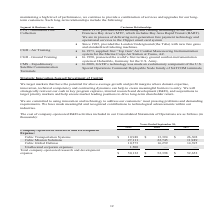According to Cubic's financial document, Which markets does the company target? markets that have the potential for above-average growth and profit margins where domain expertise, innovation, technical competency and contracting dynamics can help to create meaningful barriers to entry.. The document states: "Innovation-focused Investment of Capital We target markets that have the potential for above-average growth and profit margins where domain expertise,..." Also, Where will the company strategically reinvest their cash? in key program captures, internal research and development (R&D), and acquisitions to target priority markets and help ensure market leading positions to drive long-term shareholder return. The document states: "to entry. We will strategically reinvest our cash in key program captures, internal research and development (R&D), and acquisitions to target priorit..." Also, What are the types of company-sponsored R&D activities in the table? The document contains multiple relevant values: Cubic Transportation Systems, Cubic Mission Solutions, Cubic Global Defense, Unallocated corporate expenses. From the document: "Cubic Mission Solutions 27,111 22,745 11,949 Cubic Global Defense 10,573 16,259 14,395 Unallocated corporate expenses 1,500 — — Total company-sponsore..." Also, How many types of company-sponsored R&D activities are there in the table? Counting the relevant items in the document: Cubic Transportation Systems, Cubic Mission Solutions, Cubic Global Defense, Unallocated corporate expenses, I find 4 instances. The key data points involved are: Cubic Global Defense, Cubic Mission Solutions, Cubic Transportation Systems. Also, can you calculate: What is the change in the total company-sponsored research and development expense in 2019 from 2018? Based on the calculation: 50,132-52,398, the result is -2266 (in thousands). This is based on the information: "pany-sponsored research and development expense $ 50,132 $ 52,398 $ 52,652 sored research and development expense $ 50,132 $ 52,398 $ 52,652..." The key data points involved are: 50,132, 52,398. Also, can you calculate: What is the percentage change in Cubic Mission Solutions in 2019 from 2018? To answer this question, I need to perform calculations using the financial data. The calculation is: (27,111-22,745)/22,745, which equals 19.2 (percentage). This is based on the information: "Cubic Mission Solutions 27,111 22,745 11,949 Cubic Global Defense 10,573 16,259 14,395 Cubic Mission Solutions 27,111 22,745 11,949 Cubic Global Defense 10,573 16,259 14,395..." The key data points involved are: 22,745, 27,111. 